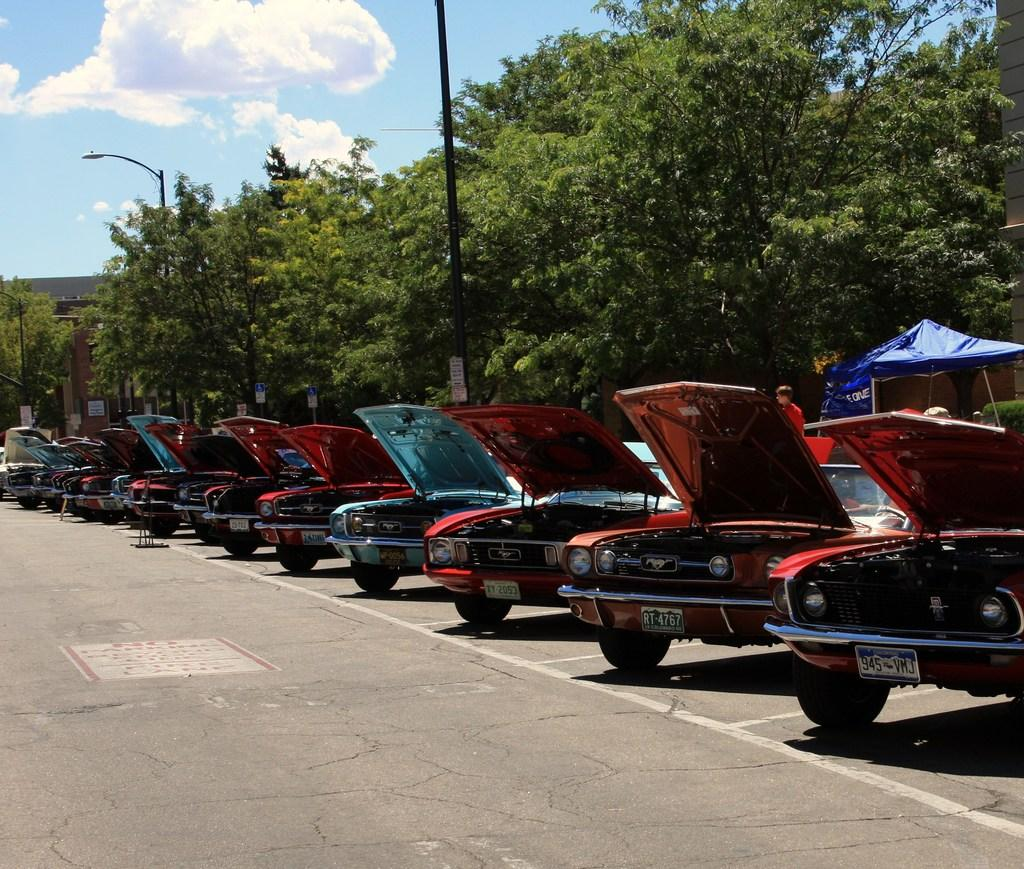What can be seen in the center of the image? There are cars parked on the road in the center of the image. What type of vegetation is on the right side of the image? There are trees on the right side of the image. What objects are present in the image that are not related to the cars or trees? There are poles in the image. How would you describe the weather in the image? The sky is cloudy in the image, suggesting a potentially overcast or rainy day. What type of soap is hanging from the trees in the image? There is no soap present in the image; it features cars parked on the road, trees, poles, and a cloudy sky. 